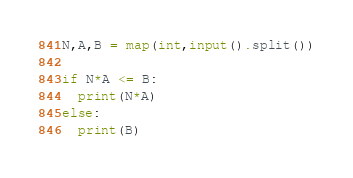<code> <loc_0><loc_0><loc_500><loc_500><_Python_>N,A,B = map(int,input().split())

if N*A <= B:
  print(N*A)
else:
  print(B)</code> 